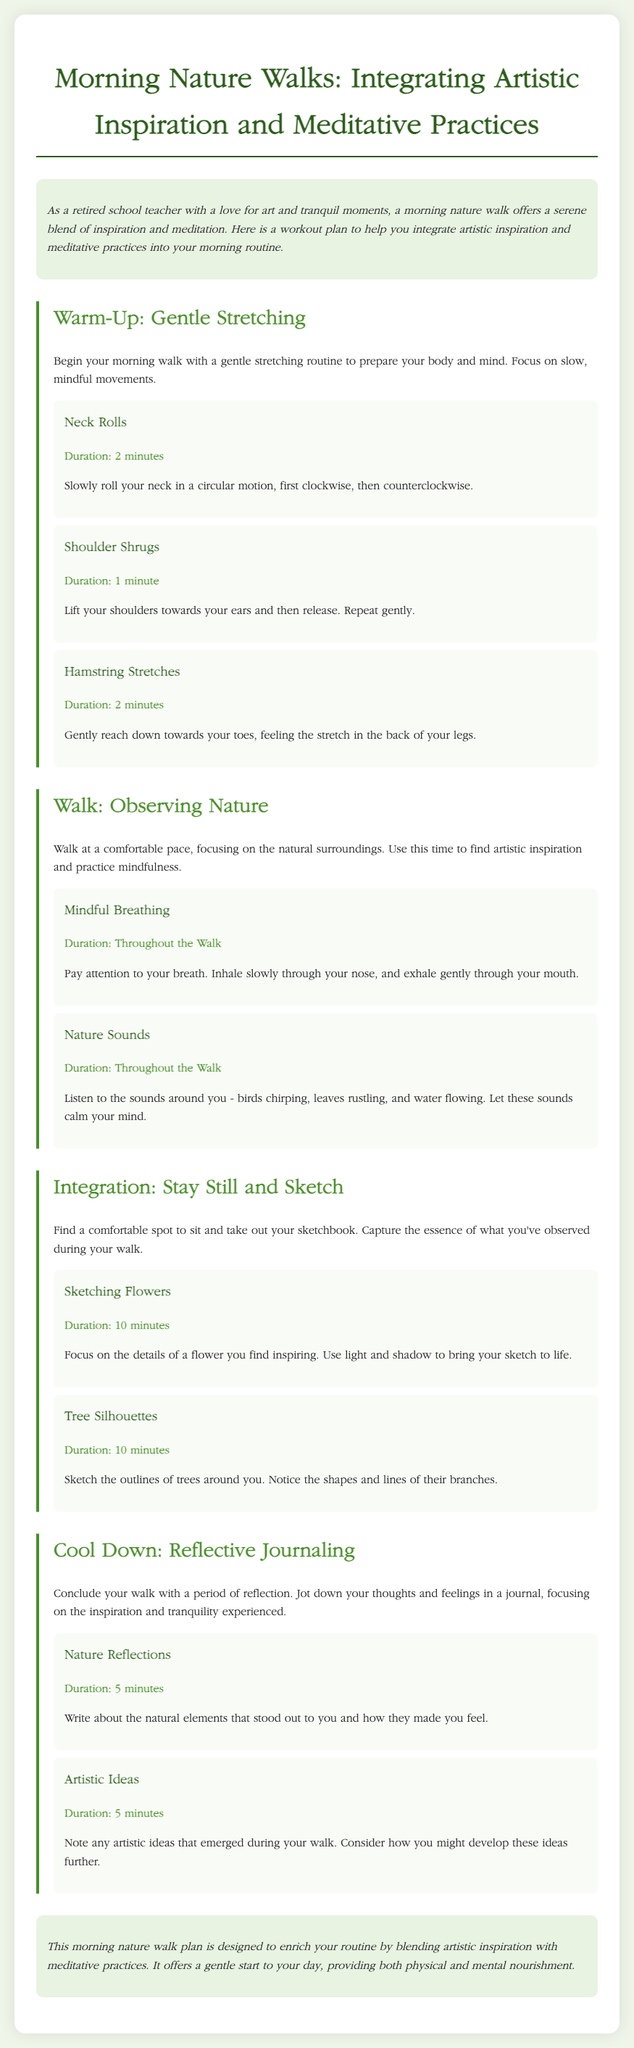What is the title of the document? The title is found in the header of the document, stating the focus of the workout plan.
Answer: Morning Nature Walks: Integrating Artistic Inspiration and Meditative Practices How long should you do neck rolls? The duration is specified under the neck rolls section, indicating how long the activity should last.
Answer: 2 minutes What activity involves listening to nature sounds? This activity is mentioned in the section where the walk is described, focusing on mindfulness during the walk.
Answer: Nature Sounds What should you write about during reflective journaling? This information is provided in the cool down section, explaining the focus of the journaling exercise.
Answer: Nature Reflections How many minutes should you sketch flowers? The duration for this activity is noted under the integration section, indicating the time allocated for sketching flowers.
Answer: 10 minutes What is the main purpose of the morning nature walk plan? The purpose described in the introduction captures the essence of the workout plan.
Answer: Enrich your routine What type of movements should you focus on during warm-up? This is explained in the warm-up section, highlighting the nature of the movements to engage in.
Answer: Mindful movements Which two activities are suggested for integration after the walk? These activities can be found in the integration section and involve artistic expression.
Answer: Sketching Flowers and Tree Silhouettes What color is used for the section titles? The color is specified for section headers in the styling of the document.
Answer: #4a8f29 